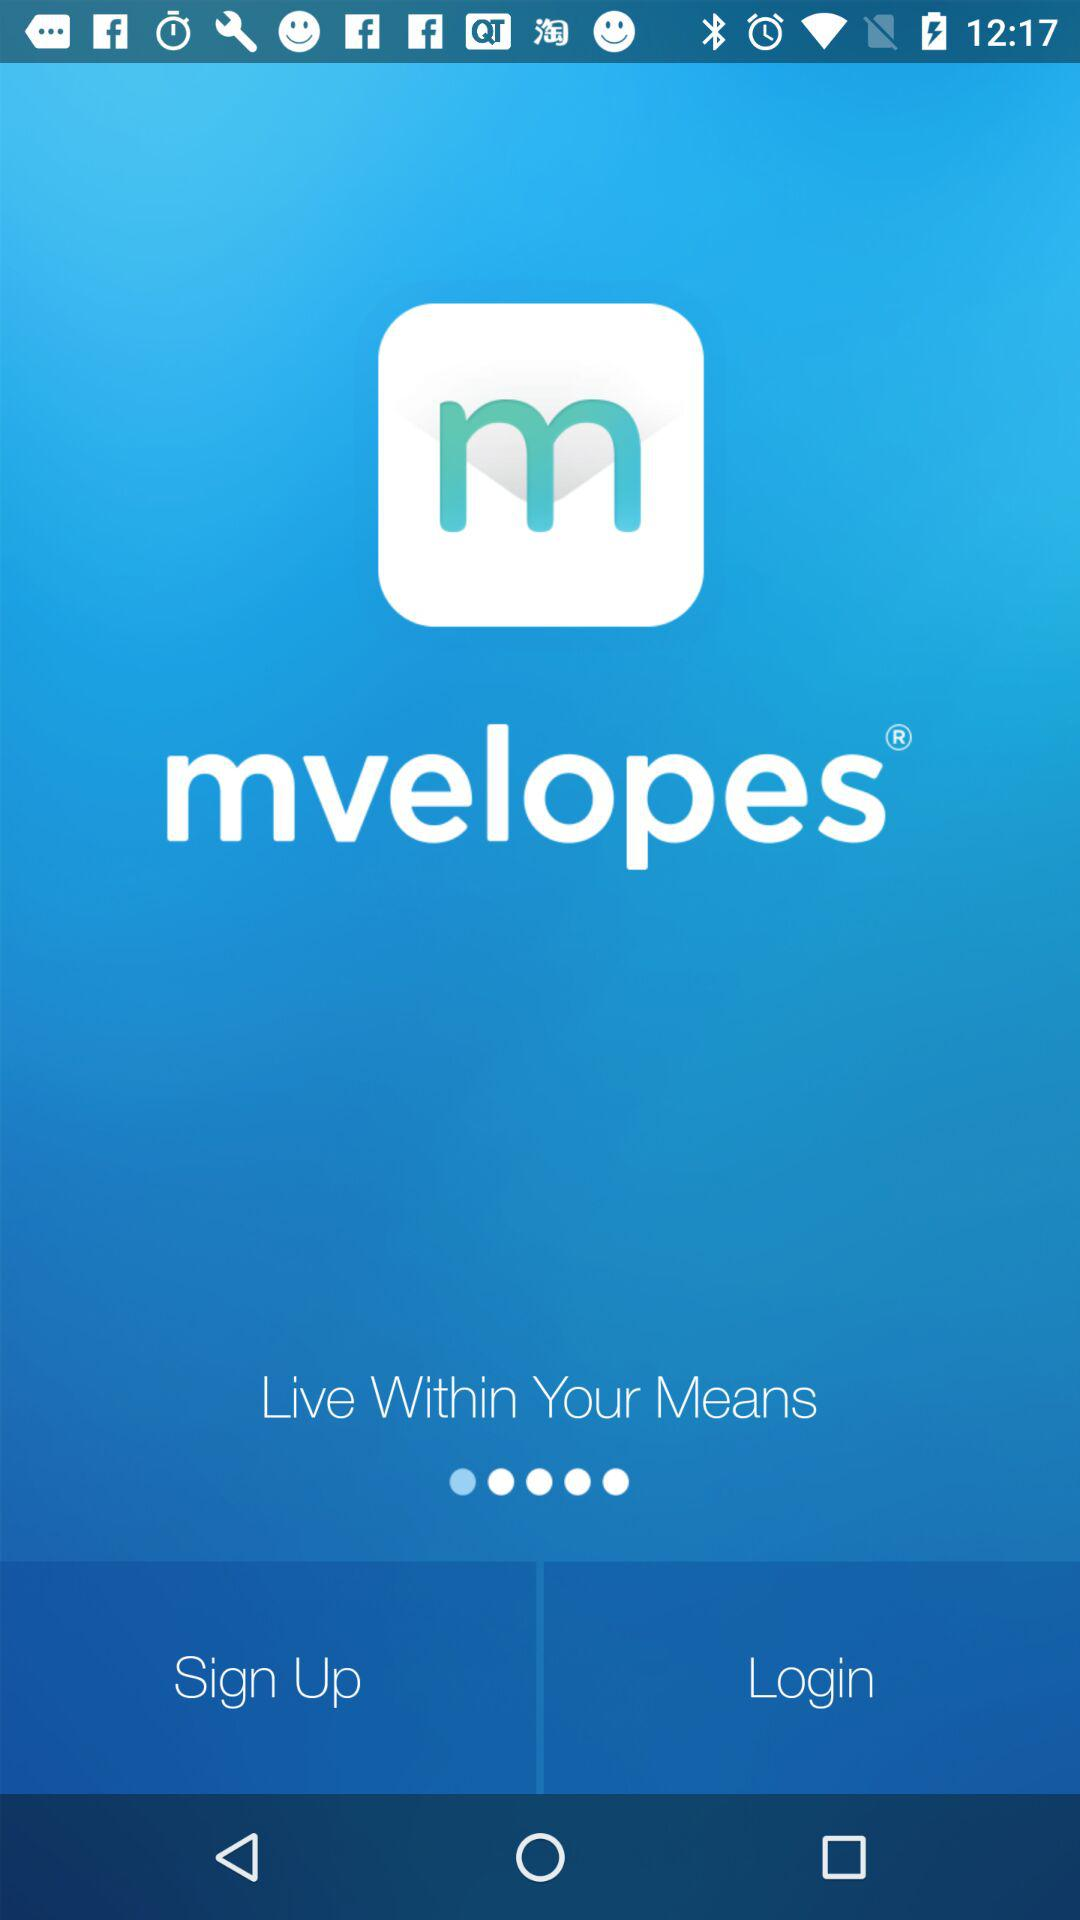Which tab is selected?
When the provided information is insufficient, respond with <no answer>. <no answer> 